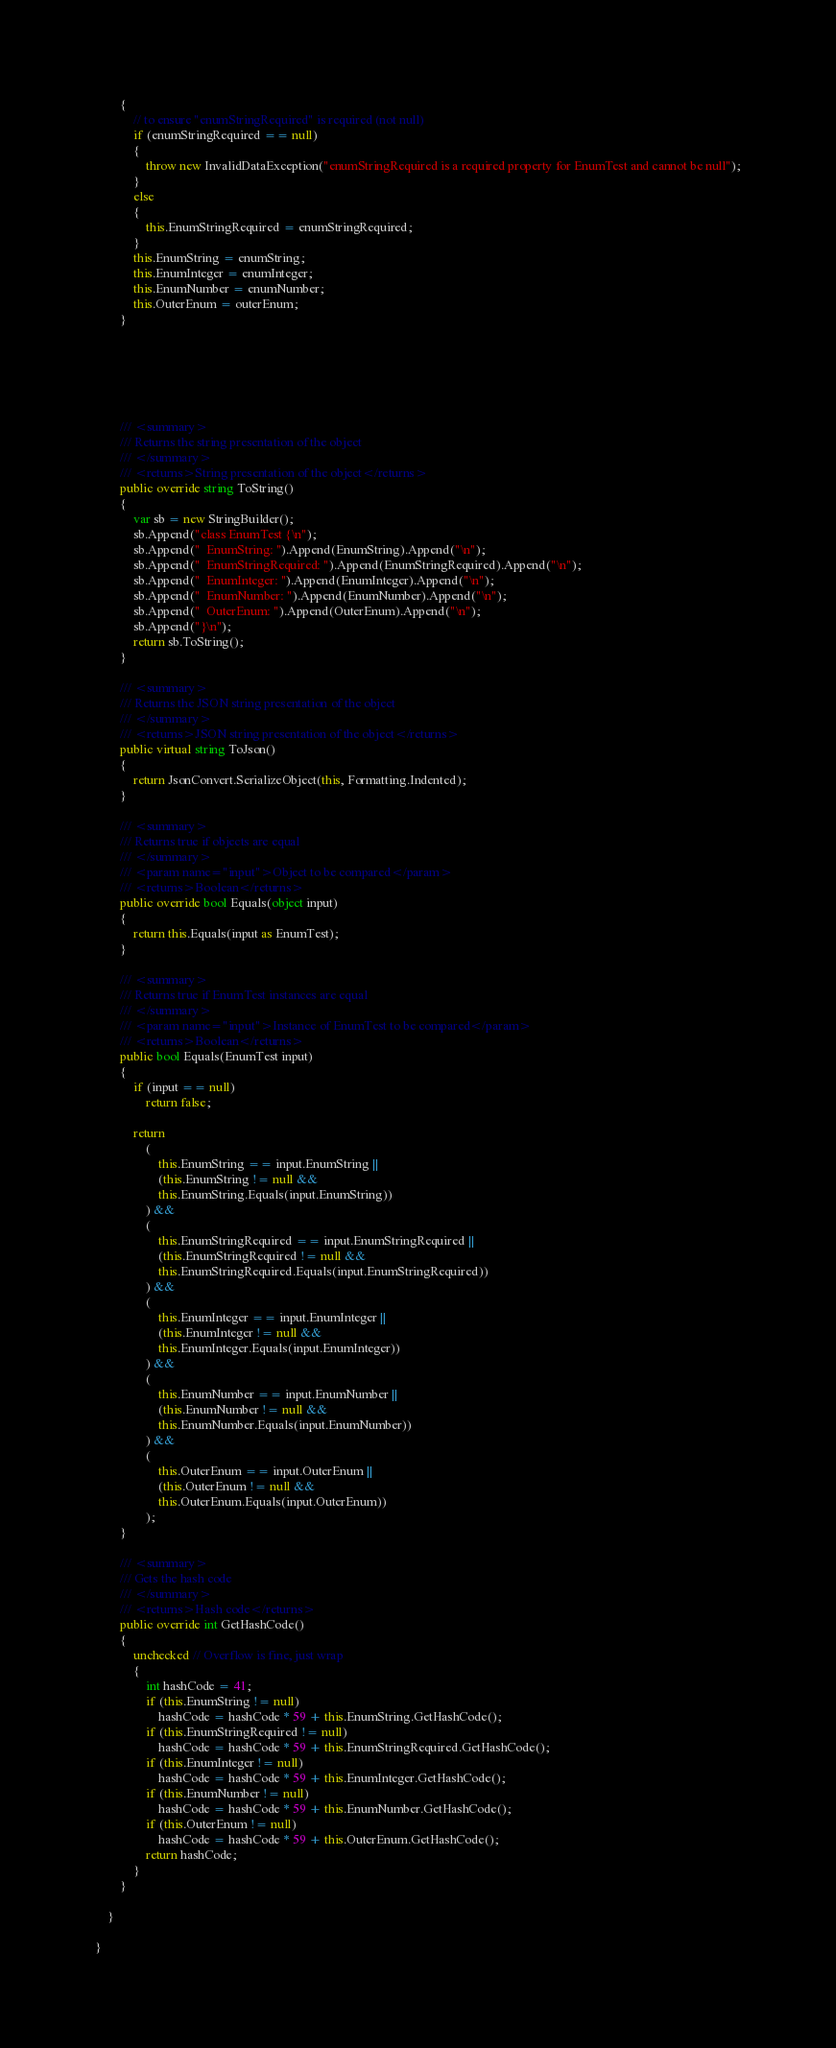Convert code to text. <code><loc_0><loc_0><loc_500><loc_500><_C#_>        {
            // to ensure "enumStringRequired" is required (not null)
            if (enumStringRequired == null)
            {
                throw new InvalidDataException("enumStringRequired is a required property for EnumTest and cannot be null");
            }
            else
            {
                this.EnumStringRequired = enumStringRequired;
            }
            this.EnumString = enumString;
            this.EnumInteger = enumInteger;
            this.EnumNumber = enumNumber;
            this.OuterEnum = outerEnum;
        }
        





        /// <summary>
        /// Returns the string presentation of the object
        /// </summary>
        /// <returns>String presentation of the object</returns>
        public override string ToString()
        {
            var sb = new StringBuilder();
            sb.Append("class EnumTest {\n");
            sb.Append("  EnumString: ").Append(EnumString).Append("\n");
            sb.Append("  EnumStringRequired: ").Append(EnumStringRequired).Append("\n");
            sb.Append("  EnumInteger: ").Append(EnumInteger).Append("\n");
            sb.Append("  EnumNumber: ").Append(EnumNumber).Append("\n");
            sb.Append("  OuterEnum: ").Append(OuterEnum).Append("\n");
            sb.Append("}\n");
            return sb.ToString();
        }
  
        /// <summary>
        /// Returns the JSON string presentation of the object
        /// </summary>
        /// <returns>JSON string presentation of the object</returns>
        public virtual string ToJson()
        {
            return JsonConvert.SerializeObject(this, Formatting.Indented);
        }

        /// <summary>
        /// Returns true if objects are equal
        /// </summary>
        /// <param name="input">Object to be compared</param>
        /// <returns>Boolean</returns>
        public override bool Equals(object input)
        {
            return this.Equals(input as EnumTest);
        }

        /// <summary>
        /// Returns true if EnumTest instances are equal
        /// </summary>
        /// <param name="input">Instance of EnumTest to be compared</param>
        /// <returns>Boolean</returns>
        public bool Equals(EnumTest input)
        {
            if (input == null)
                return false;

            return 
                (
                    this.EnumString == input.EnumString ||
                    (this.EnumString != null &&
                    this.EnumString.Equals(input.EnumString))
                ) && 
                (
                    this.EnumStringRequired == input.EnumStringRequired ||
                    (this.EnumStringRequired != null &&
                    this.EnumStringRequired.Equals(input.EnumStringRequired))
                ) && 
                (
                    this.EnumInteger == input.EnumInteger ||
                    (this.EnumInteger != null &&
                    this.EnumInteger.Equals(input.EnumInteger))
                ) && 
                (
                    this.EnumNumber == input.EnumNumber ||
                    (this.EnumNumber != null &&
                    this.EnumNumber.Equals(input.EnumNumber))
                ) && 
                (
                    this.OuterEnum == input.OuterEnum ||
                    (this.OuterEnum != null &&
                    this.OuterEnum.Equals(input.OuterEnum))
                );
        }

        /// <summary>
        /// Gets the hash code
        /// </summary>
        /// <returns>Hash code</returns>
        public override int GetHashCode()
        {
            unchecked // Overflow is fine, just wrap
            {
                int hashCode = 41;
                if (this.EnumString != null)
                    hashCode = hashCode * 59 + this.EnumString.GetHashCode();
                if (this.EnumStringRequired != null)
                    hashCode = hashCode * 59 + this.EnumStringRequired.GetHashCode();
                if (this.EnumInteger != null)
                    hashCode = hashCode * 59 + this.EnumInteger.GetHashCode();
                if (this.EnumNumber != null)
                    hashCode = hashCode * 59 + this.EnumNumber.GetHashCode();
                if (this.OuterEnum != null)
                    hashCode = hashCode * 59 + this.OuterEnum.GetHashCode();
                return hashCode;
            }
        }

    }

}
</code> 